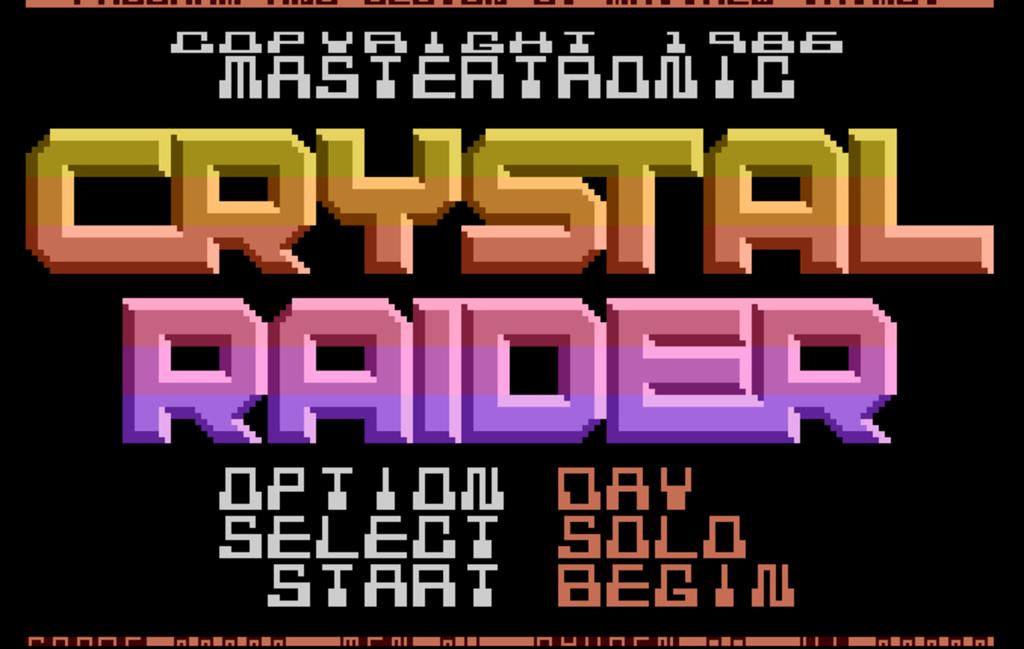When was this copyrighted?
Ensure brevity in your answer.  1986. What is the video game name?
Make the answer very short. Crystal raider. 